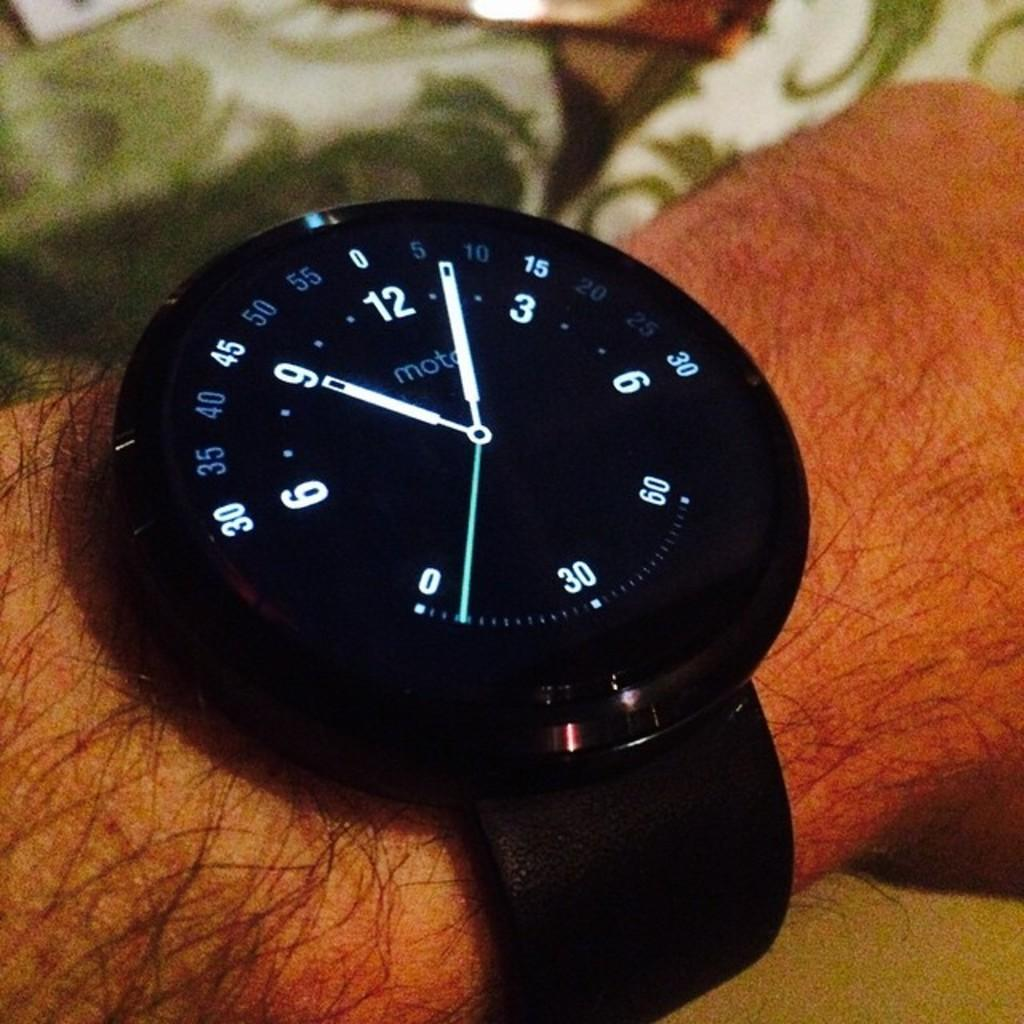<image>
Share a concise interpretation of the image provided. A moto watch with white hands is on someone's wrist. 